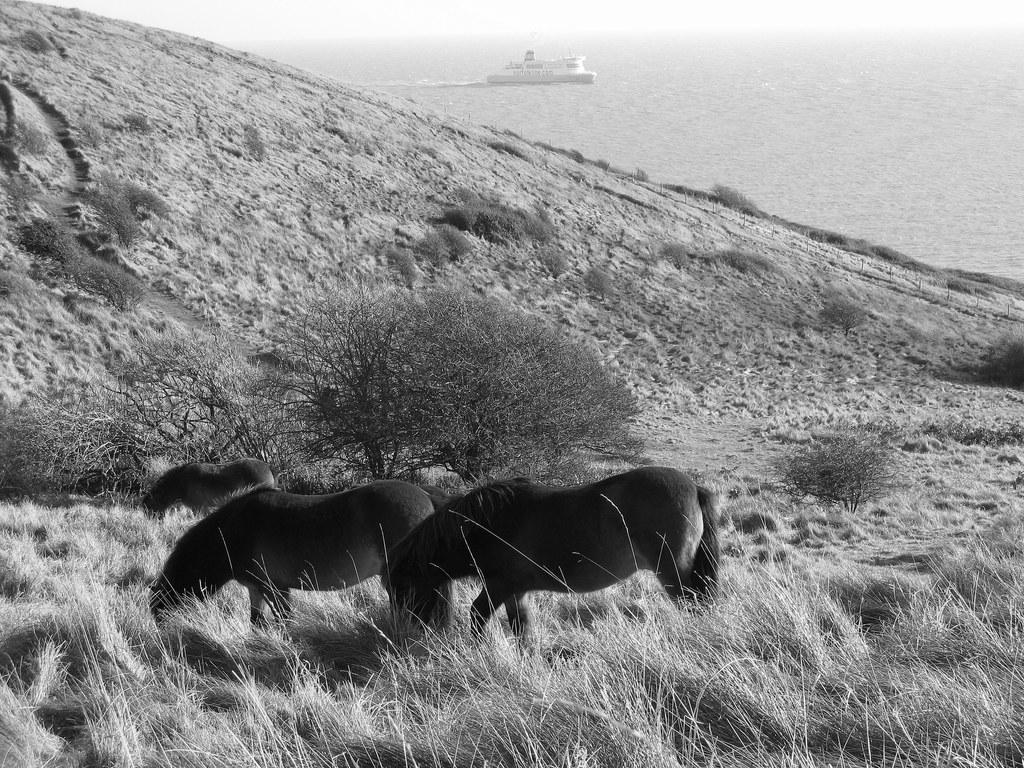What is the color scheme of the image? The image is black and white. What geographical feature can be seen in the image? There is a hill in the image. How many animals are present in the image? There are three animals in the image. What are the animals doing in the image? The animals are eating grass. What type of vegetation is present in the image? There are trees in the image. What is visible in the background of the image? There is a ship in the background of the image. What is the ship's location in relation to the water? The ship is on water. Can you tell me how many buckets are being used by the animals to collect water in the image? There are no buckets present in the image; the animals are eating grass. What historical event is depicted in the image? There is no historical event depicted in the image; it features a hill, trees, a ship, and animals eating grass. 